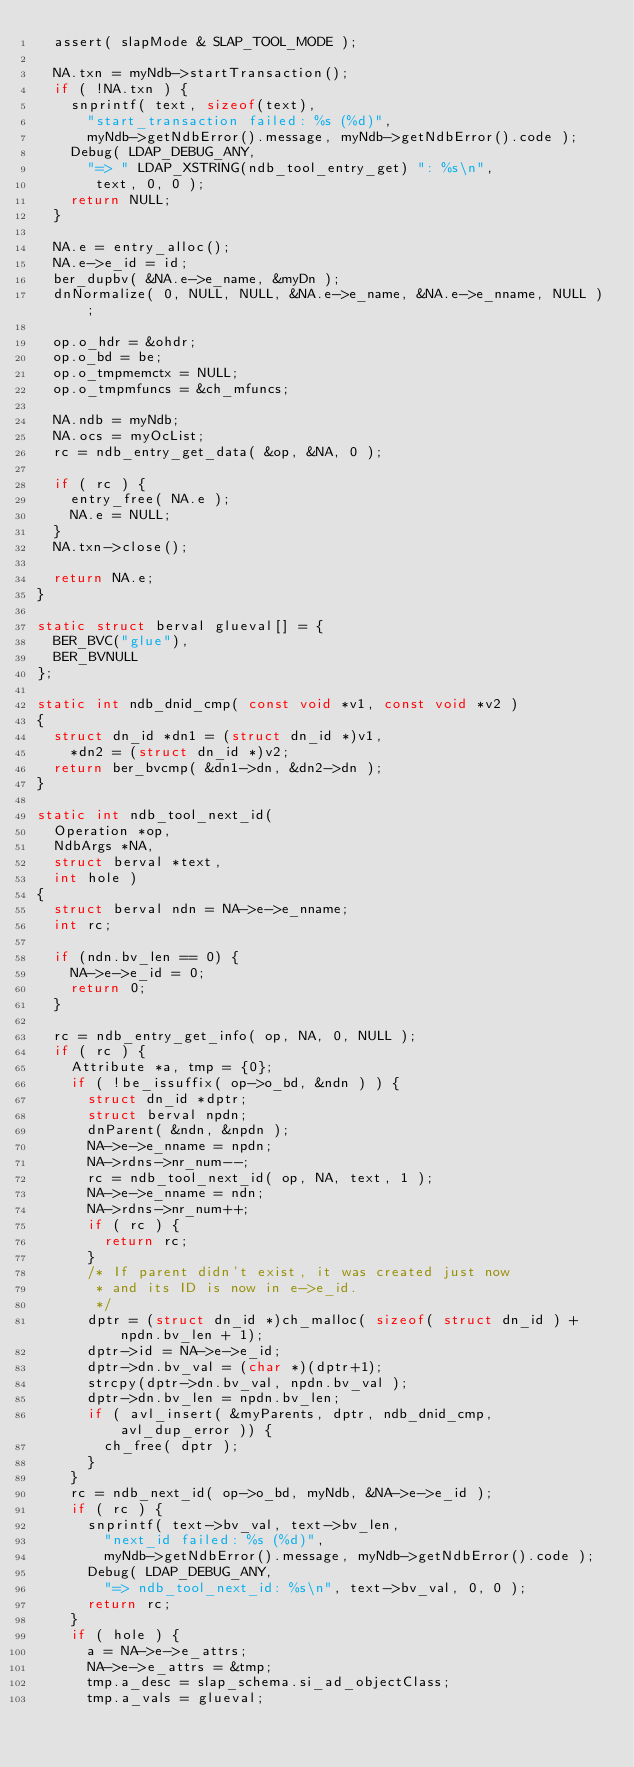Convert code to text. <code><loc_0><loc_0><loc_500><loc_500><_C++_>	assert( slapMode & SLAP_TOOL_MODE );

	NA.txn = myNdb->startTransaction();
	if ( !NA.txn ) {
		snprintf( text, sizeof(text),
			"start_transaction failed: %s (%d)",
			myNdb->getNdbError().message, myNdb->getNdbError().code );
		Debug( LDAP_DEBUG_ANY,
			"=> " LDAP_XSTRING(ndb_tool_entry_get) ": %s\n",
			 text, 0, 0 );
		return NULL;
	}

	NA.e = entry_alloc();
	NA.e->e_id = id;
	ber_dupbv( &NA.e->e_name, &myDn );
	dnNormalize( 0, NULL, NULL, &NA.e->e_name, &NA.e->e_nname, NULL );

	op.o_hdr = &ohdr;
	op.o_bd = be;
	op.o_tmpmemctx = NULL;
	op.o_tmpmfuncs = &ch_mfuncs;

	NA.ndb = myNdb;
	NA.ocs = myOcList;
	rc = ndb_entry_get_data( &op, &NA, 0 );

	if ( rc ) {
		entry_free( NA.e );
		NA.e = NULL;
	}
	NA.txn->close();

	return NA.e;
}

static struct berval glueval[] = {
	BER_BVC("glue"),
	BER_BVNULL
};

static int ndb_dnid_cmp( const void *v1, const void *v2 )
{
	struct dn_id *dn1 = (struct dn_id *)v1,
		*dn2 = (struct dn_id *)v2;
	return ber_bvcmp( &dn1->dn, &dn2->dn );
}

static int ndb_tool_next_id(
	Operation *op,
	NdbArgs *NA,
	struct berval *text,
	int hole )
{
	struct berval ndn = NA->e->e_nname;
	int rc;

	if (ndn.bv_len == 0) {
		NA->e->e_id = 0;
		return 0;
	}

	rc = ndb_entry_get_info( op, NA, 0, NULL );
	if ( rc ) {
		Attribute *a, tmp = {0};
		if ( !be_issuffix( op->o_bd, &ndn ) ) {
			struct dn_id *dptr;
			struct berval npdn;
			dnParent( &ndn, &npdn );
			NA->e->e_nname = npdn;
			NA->rdns->nr_num--;
			rc = ndb_tool_next_id( op, NA, text, 1 );
			NA->e->e_nname = ndn;
			NA->rdns->nr_num++;
			if ( rc ) {
				return rc;
			}
			/* If parent didn't exist, it was created just now
			 * and its ID is now in e->e_id.
			 */
			dptr = (struct dn_id *)ch_malloc( sizeof( struct dn_id ) + npdn.bv_len + 1);
			dptr->id = NA->e->e_id;
			dptr->dn.bv_val = (char *)(dptr+1);
			strcpy(dptr->dn.bv_val, npdn.bv_val );
			dptr->dn.bv_len = npdn.bv_len;
			if ( avl_insert( &myParents, dptr, ndb_dnid_cmp, avl_dup_error )) {
				ch_free( dptr );
			}
		}
		rc = ndb_next_id( op->o_bd, myNdb, &NA->e->e_id );
		if ( rc ) {
			snprintf( text->bv_val, text->bv_len,
				"next_id failed: %s (%d)",
				myNdb->getNdbError().message, myNdb->getNdbError().code );
			Debug( LDAP_DEBUG_ANY,
				"=> ndb_tool_next_id: %s\n", text->bv_val, 0, 0 );
			return rc;
		}
		if ( hole ) {
			a = NA->e->e_attrs;
			NA->e->e_attrs = &tmp;
			tmp.a_desc = slap_schema.si_ad_objectClass;
			tmp.a_vals = glueval;</code> 